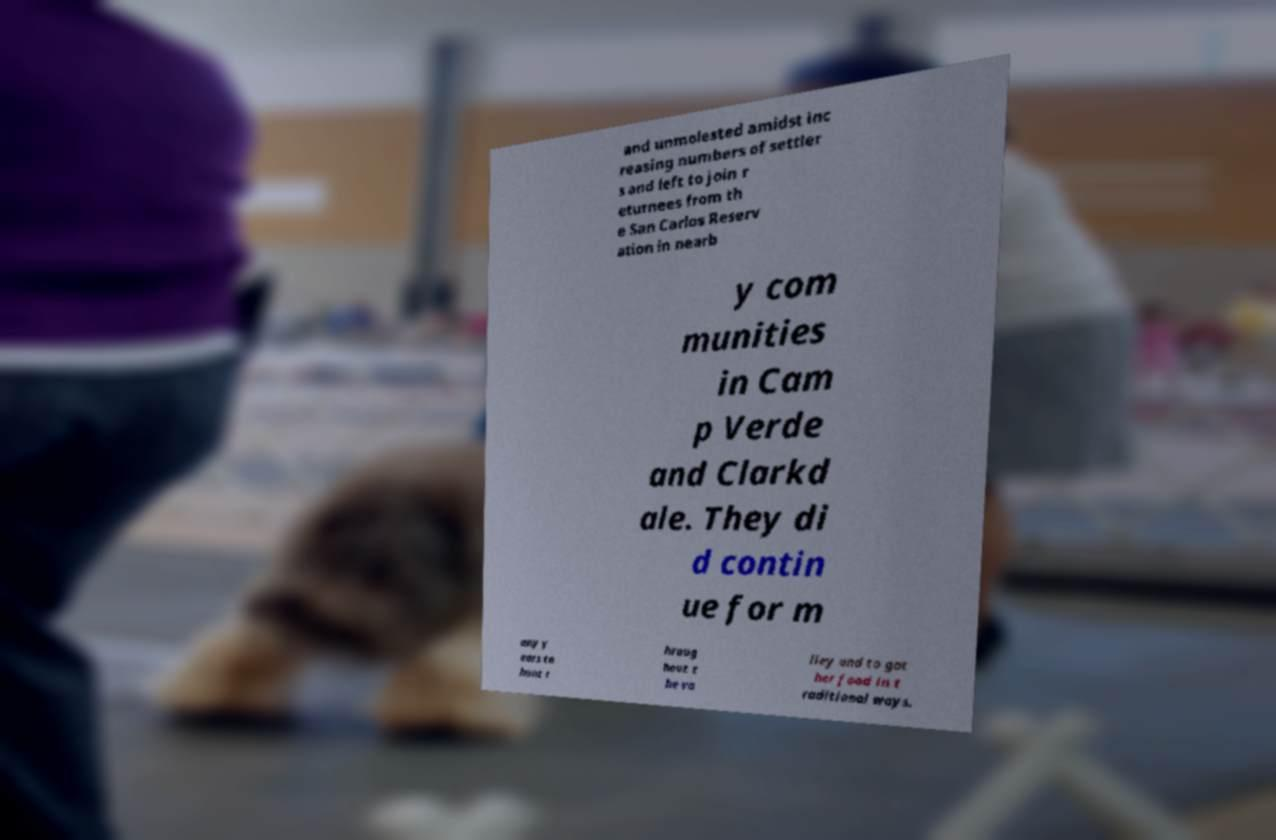Could you extract and type out the text from this image? and unmolested amidst inc reasing numbers of settler s and left to join r eturnees from th e San Carlos Reserv ation in nearb y com munities in Cam p Verde and Clarkd ale. They di d contin ue for m any y ears to hunt t hroug hout t he va lley and to gat her food in t raditional ways. 